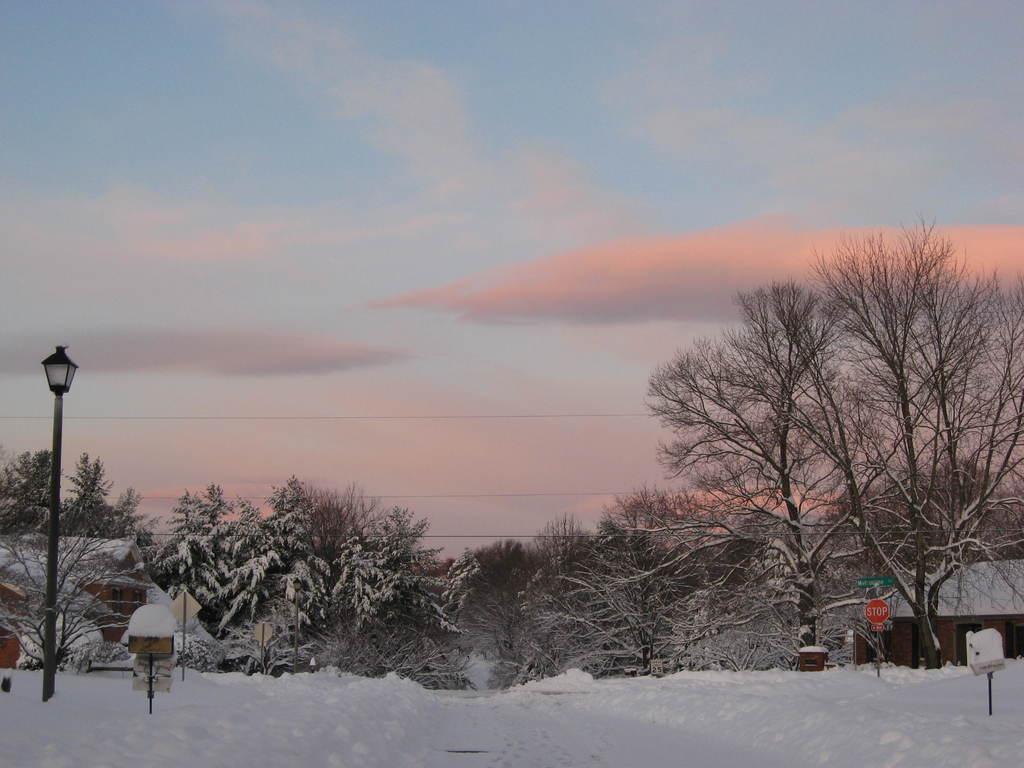How would you summarize this image in a sentence or two? In this image we can see snow on the land. In the middle of the image, there are trees, poles, sign board and house. The sky is in blue color with clouds. 